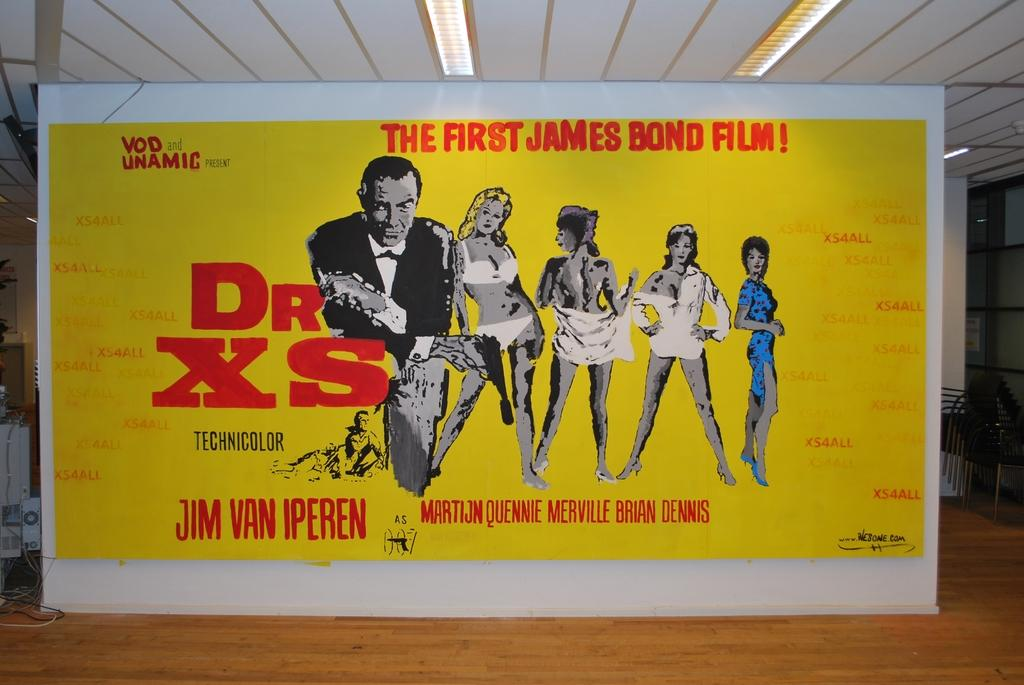<image>
Provide a brief description of the given image. A yellow poster advertises the first James Bond film, Dr XS. 